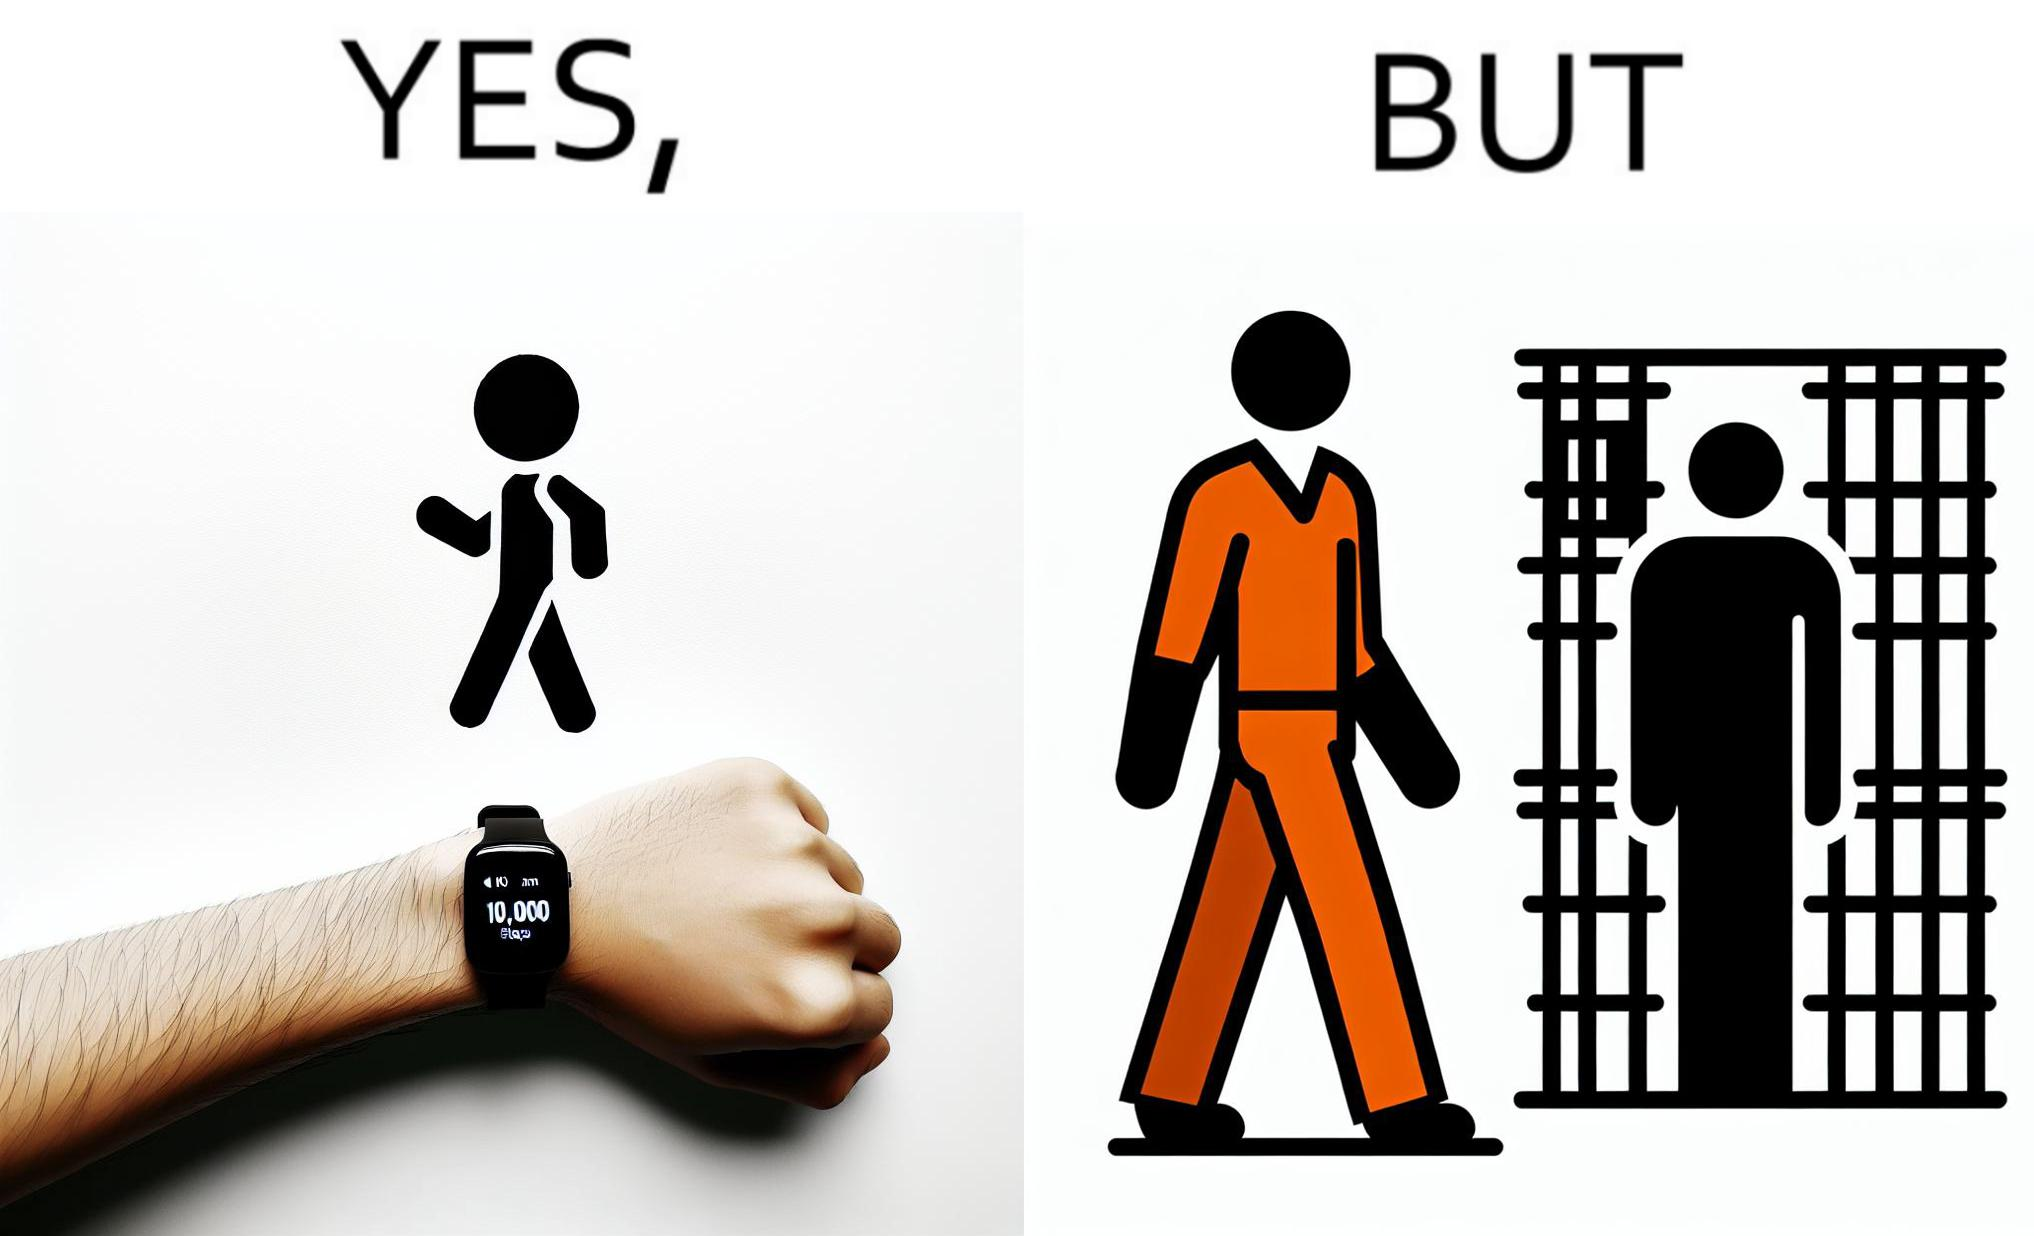Describe the content of this image. The image is ironical, as the smartwatch on the person's wrist shows 10,000 steps completed as an accomplishment, while showing later that the person is apparently walking inside a jail as a prisoner. 